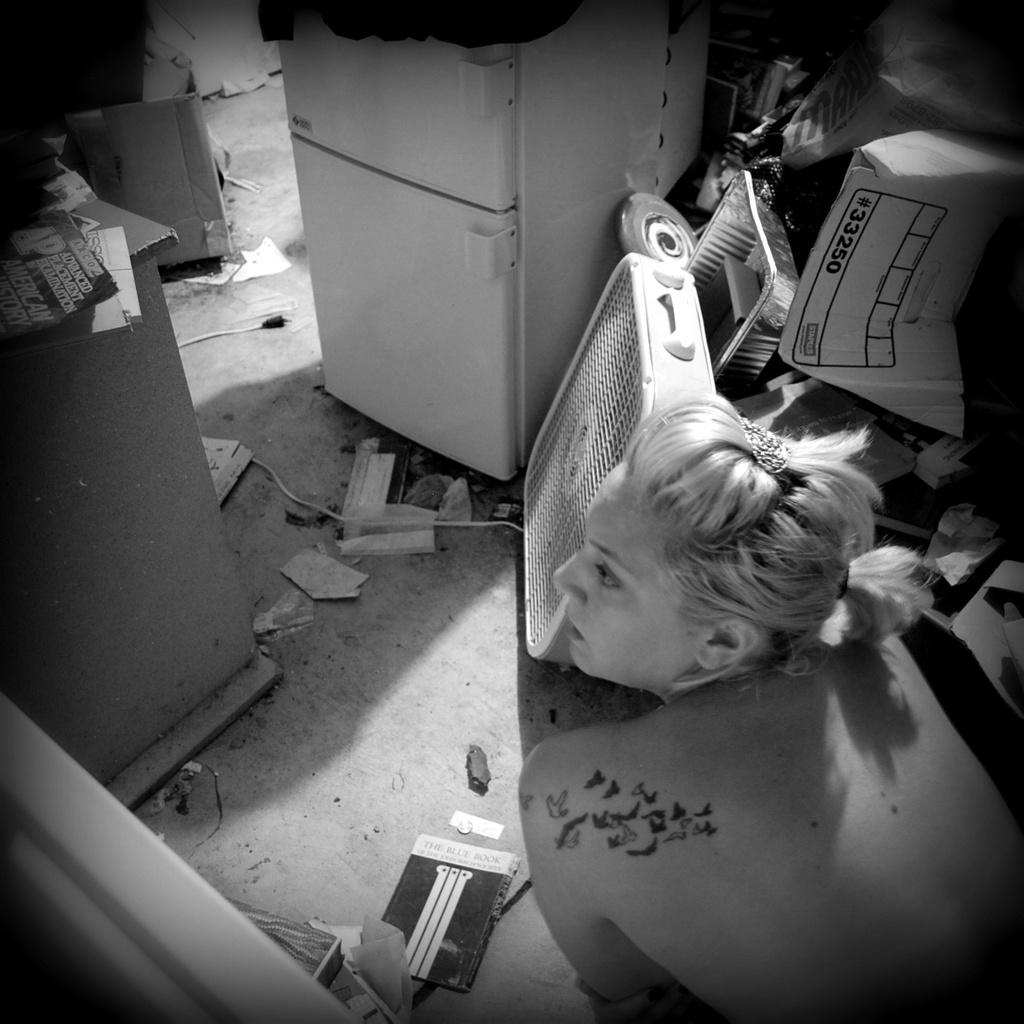Who is present on the right side of the image? There is a lady on the right side of the image. What is on the floor in the image? There are papers on the floor. What can be seen in the background of the image? There is an electronic machine, a plate, and other items visible in the background. How many snakes are crawling on the lady's head in the image? There are no snakes present in the image; the lady's head is not shown. 